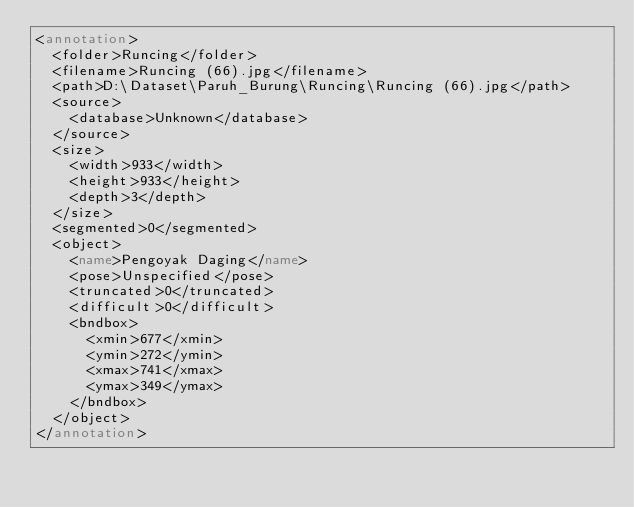Convert code to text. <code><loc_0><loc_0><loc_500><loc_500><_XML_><annotation>
	<folder>Runcing</folder>
	<filename>Runcing (66).jpg</filename>
	<path>D:\Dataset\Paruh_Burung\Runcing\Runcing (66).jpg</path>
	<source>
		<database>Unknown</database>
	</source>
	<size>
		<width>933</width>
		<height>933</height>
		<depth>3</depth>
	</size>
	<segmented>0</segmented>
	<object>
		<name>Pengoyak Daging</name>
		<pose>Unspecified</pose>
		<truncated>0</truncated>
		<difficult>0</difficult>
		<bndbox>
			<xmin>677</xmin>
			<ymin>272</ymin>
			<xmax>741</xmax>
			<ymax>349</ymax>
		</bndbox>
	</object>
</annotation>
</code> 